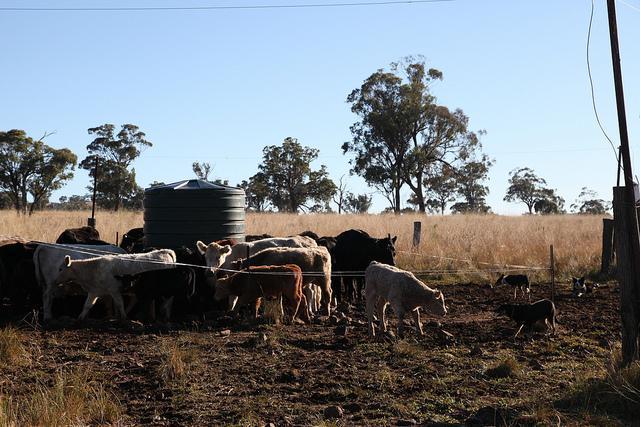How many dogs are in the photo?
Give a very brief answer. 3. How many cows can you see?
Give a very brief answer. 7. 